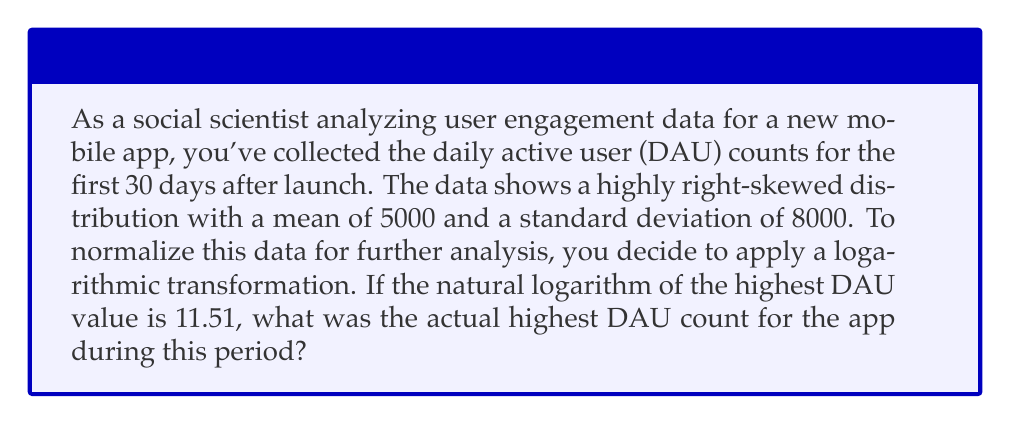Help me with this question. To solve this problem, we'll follow these steps:

1. Understand the given information:
   - The data is right-skewed
   - We're using a natural logarithm (base e) transformation
   - The highest transformed value is 11.51

2. Recall the properties of logarithms:
   If $\ln(x) = y$, then $e^y = x$

3. Set up the equation:
   $\ln(\text{highest DAU}) = 11.51$

4. Solve for the highest DAU by applying the inverse function (exponential):
   $\text{highest DAU} = e^{11.51}$

5. Calculate the result:
   $\text{highest DAU} = e^{11.51} \approx 99,484.55$

6. Round to the nearest whole number, as DAU counts are typically integers:
   $\text{highest DAU} \approx 99,485$

This result aligns with the right-skewed nature of the data, as it's significantly higher than the mean of 5000.
Answer: 99,485 